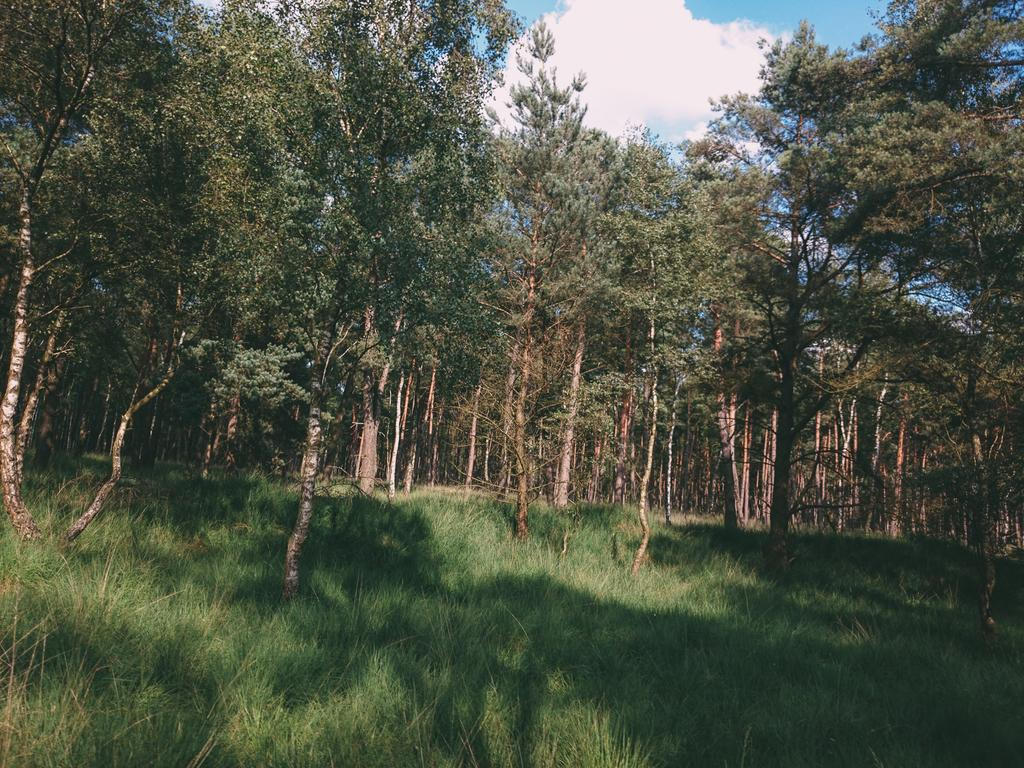What type of surface is visible in the image? There is grass on the surface in the image. What other natural elements can be seen in the image? There are trees in the image. What is visible in the background of the image? The sky is visible in the background of the image. What note is written on the tree in the image? There is no note written on the tree in the image; it is a natural element without any text or markings. 